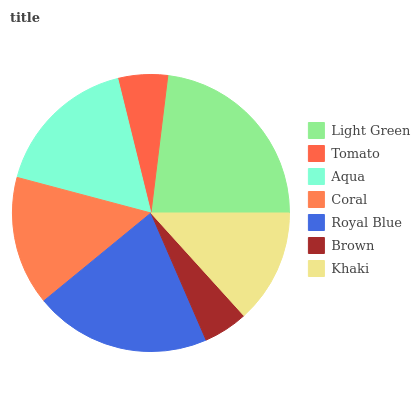Is Brown the minimum?
Answer yes or no. Yes. Is Light Green the maximum?
Answer yes or no. Yes. Is Tomato the minimum?
Answer yes or no. No. Is Tomato the maximum?
Answer yes or no. No. Is Light Green greater than Tomato?
Answer yes or no. Yes. Is Tomato less than Light Green?
Answer yes or no. Yes. Is Tomato greater than Light Green?
Answer yes or no. No. Is Light Green less than Tomato?
Answer yes or no. No. Is Coral the high median?
Answer yes or no. Yes. Is Coral the low median?
Answer yes or no. Yes. Is Aqua the high median?
Answer yes or no. No. Is Brown the low median?
Answer yes or no. No. 